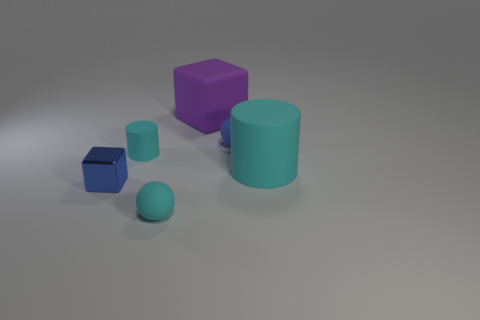Add 3 tiny blue cubes. How many objects exist? 9 Subtract all cyan spheres. Subtract all red cubes. How many spheres are left? 1 Subtract all cubes. How many objects are left? 4 Add 1 large green matte balls. How many large green matte balls exist? 1 Subtract 0 purple spheres. How many objects are left? 6 Subtract all blue objects. Subtract all large gray metallic blocks. How many objects are left? 4 Add 1 small cyan balls. How many small cyan balls are left? 2 